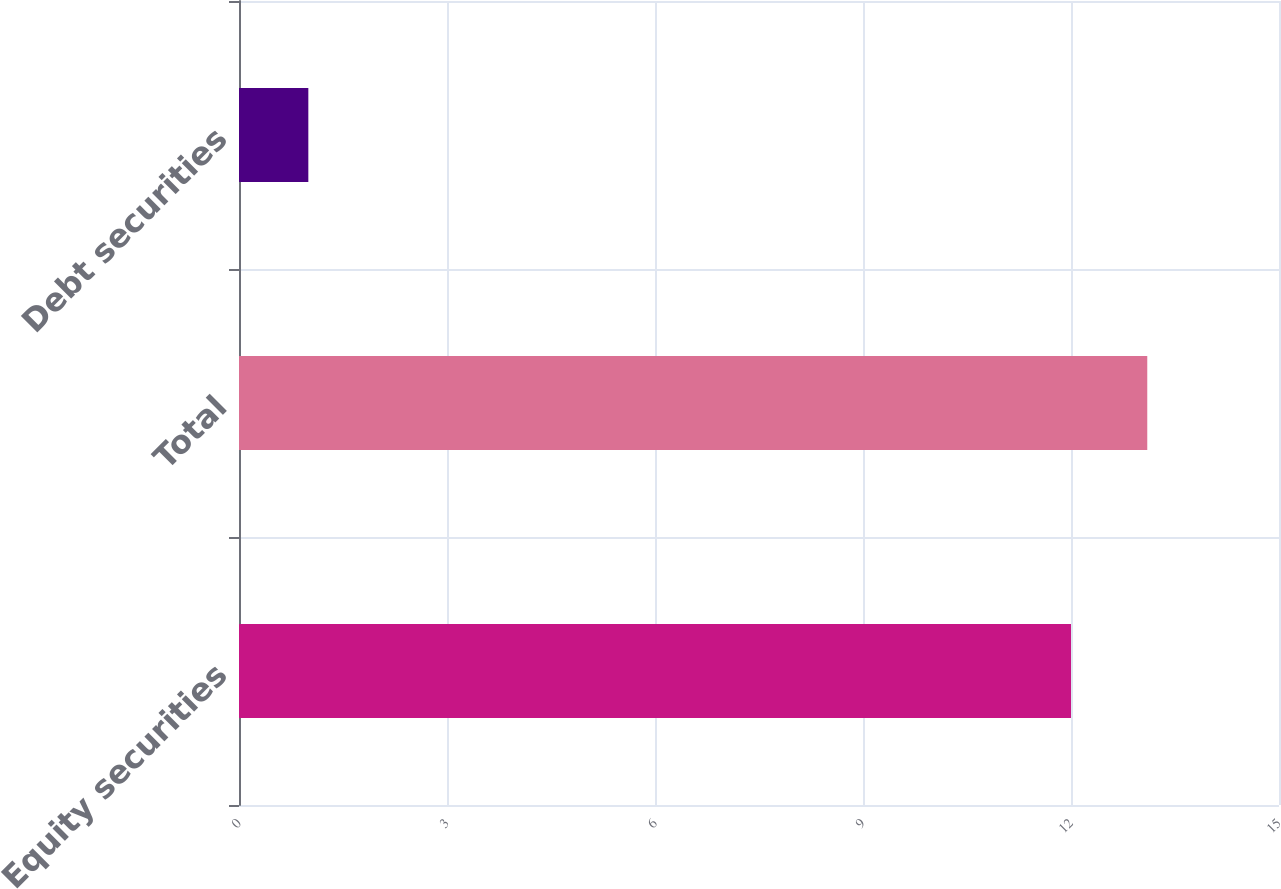Convert chart. <chart><loc_0><loc_0><loc_500><loc_500><bar_chart><fcel>Equity securities<fcel>Total<fcel>Debt securities<nl><fcel>12<fcel>13.1<fcel>1<nl></chart> 